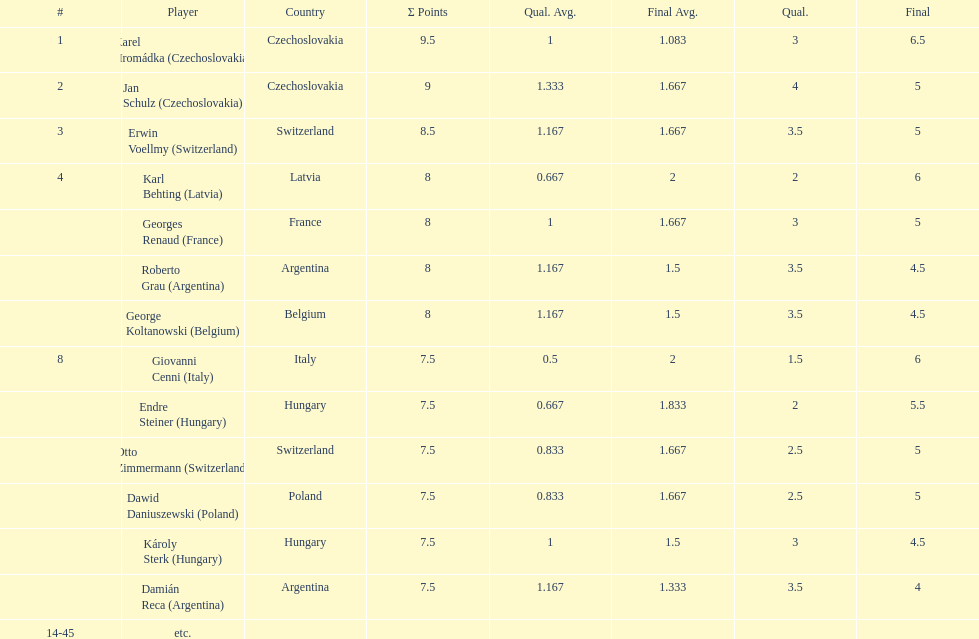Jan schulz is ranked immediately below which player? Karel Hromádka. 